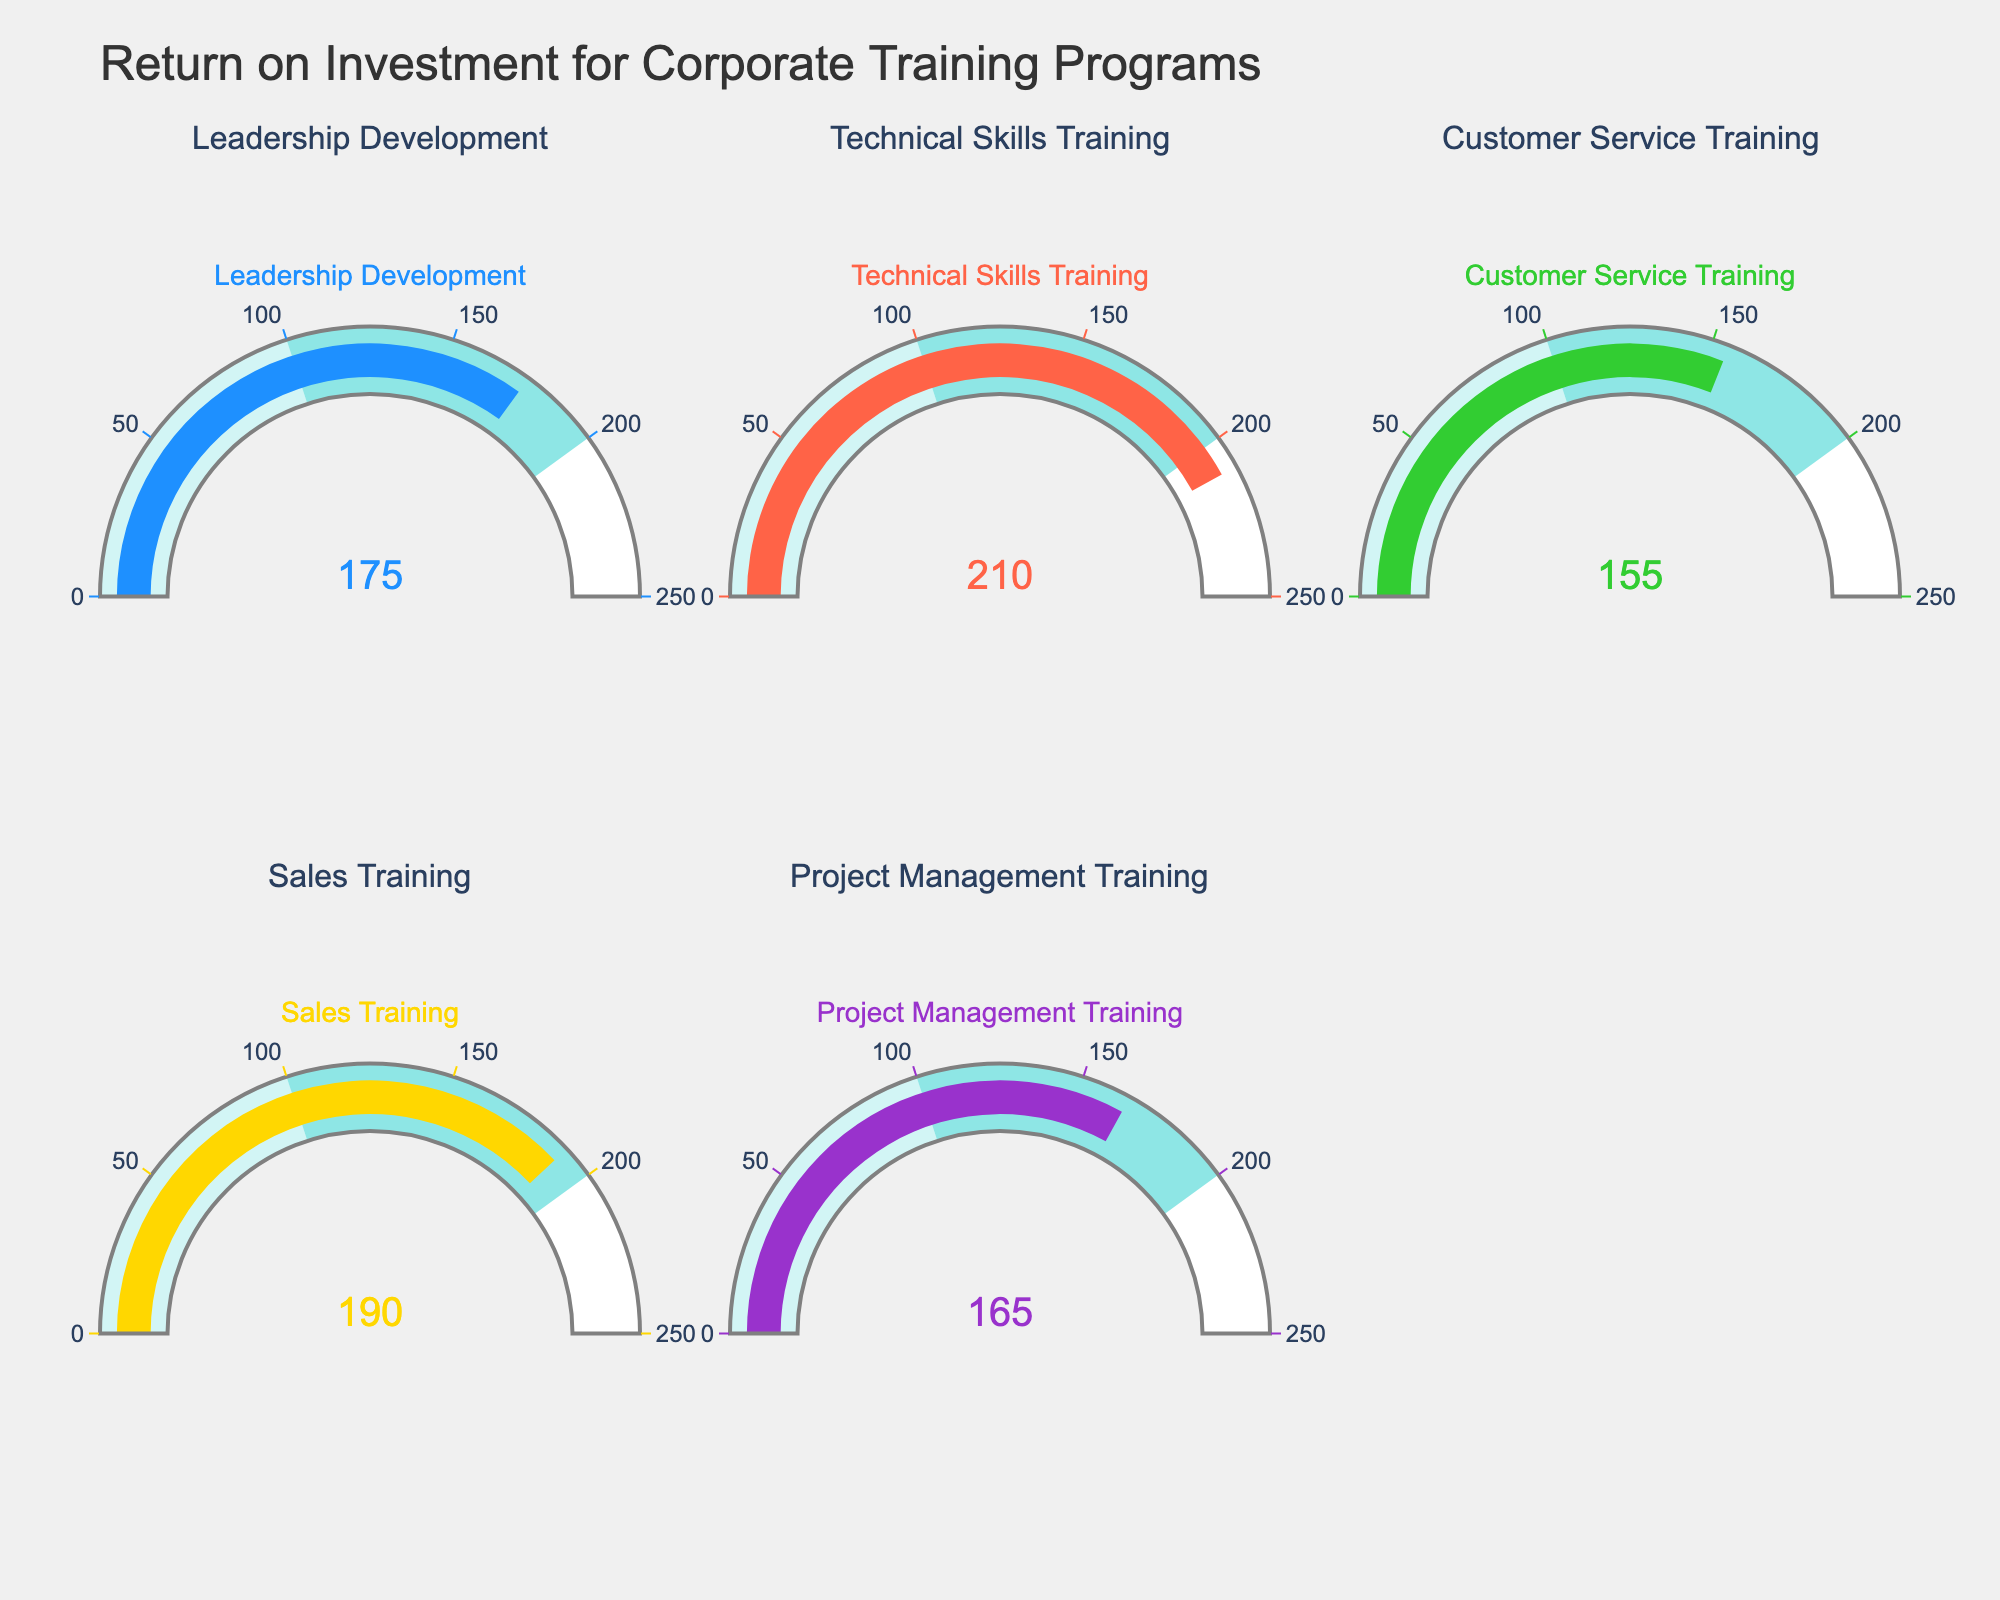What is the highest ROI value among all the training programs? The figure shows ROI values for different training programs. The highest value can be identified by comparing the numbers displayed in the gauges.
Answer: 210 Which training program has the lowest ROI? By looking at each gauge's number, the lowest value can be identified. It is for Customer Service Training with an ROI of 155.
Answer: Customer Service Training What is the average ROI across all training programs? First, sum the ROI values for each program: 175 + 210 + 155 + 190 + 165 = 895. Then, divide by the number of programs, which is 5: 895 / 5 = 179.
Answer: 179 Is the ROI of Sales Training higher than Project Management Training? Compare the numbers displayed in the gauges for Sales Training and Project Management Training. 190 is greater than 165, so yes, it is higher.
Answer: Yes What is the difference in ROI between Technical Skills Training and Customer Service Training? Subtract the ROI value of Customer Service Training from Technical Skills Training: 210 - 155 = 55.
Answer: 55 Which training program has an ROI closest to 160? Check each ROI value and see which one is closest to 160. Project Management Training with an ROI of 165 is the closest.
Answer: Project Management Training What is the combined ROI of Leadership Development and Sales Training programs? Add the ROI values of Leadership Development and Sales Training: 175 + 190 = 365.
Answer: 365 What percentage of the total ROI does the Sales Training program contribute? First, calculate the total ROI: 175 + 210 + 155 + 190 + 165 = 895. Then, determine the contribution of Sales Training: (190 / 895) * 100 ≈ 21.23%.
Answer: 21.23% Which training programs have an ROI greater than 180? Check each gauge and list those with ROI values greater than 180: Technical Skills Training (210) and Sales Training (190).
Answer: Technical Skills Training, Sales Training 